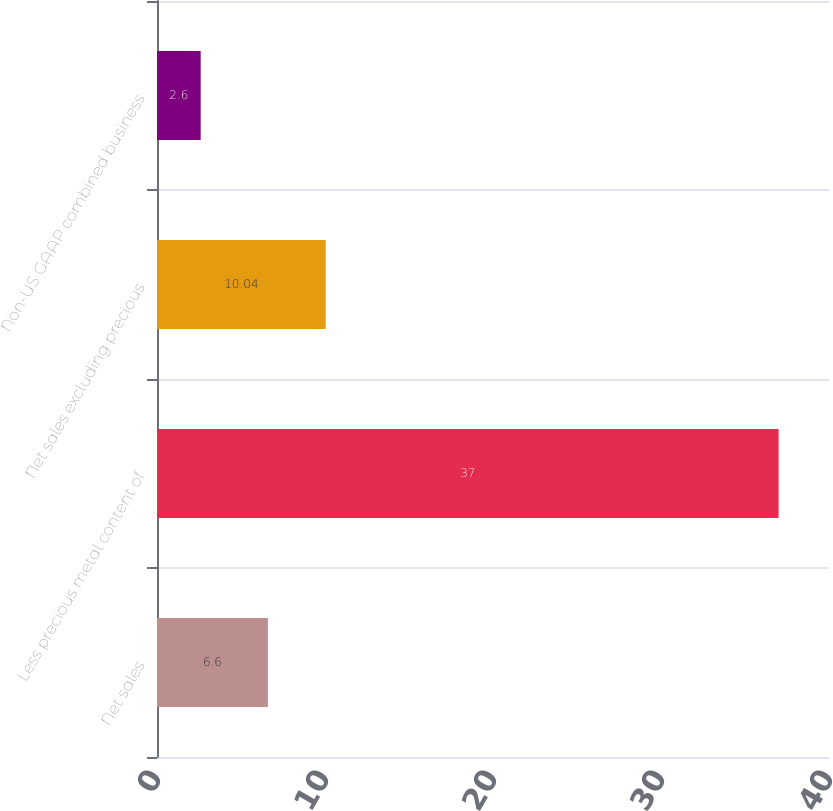<chart> <loc_0><loc_0><loc_500><loc_500><bar_chart><fcel>Net sales<fcel>Less precious metal content of<fcel>Net sales excluding precious<fcel>Non-US GAAP combined business<nl><fcel>6.6<fcel>37<fcel>10.04<fcel>2.6<nl></chart> 